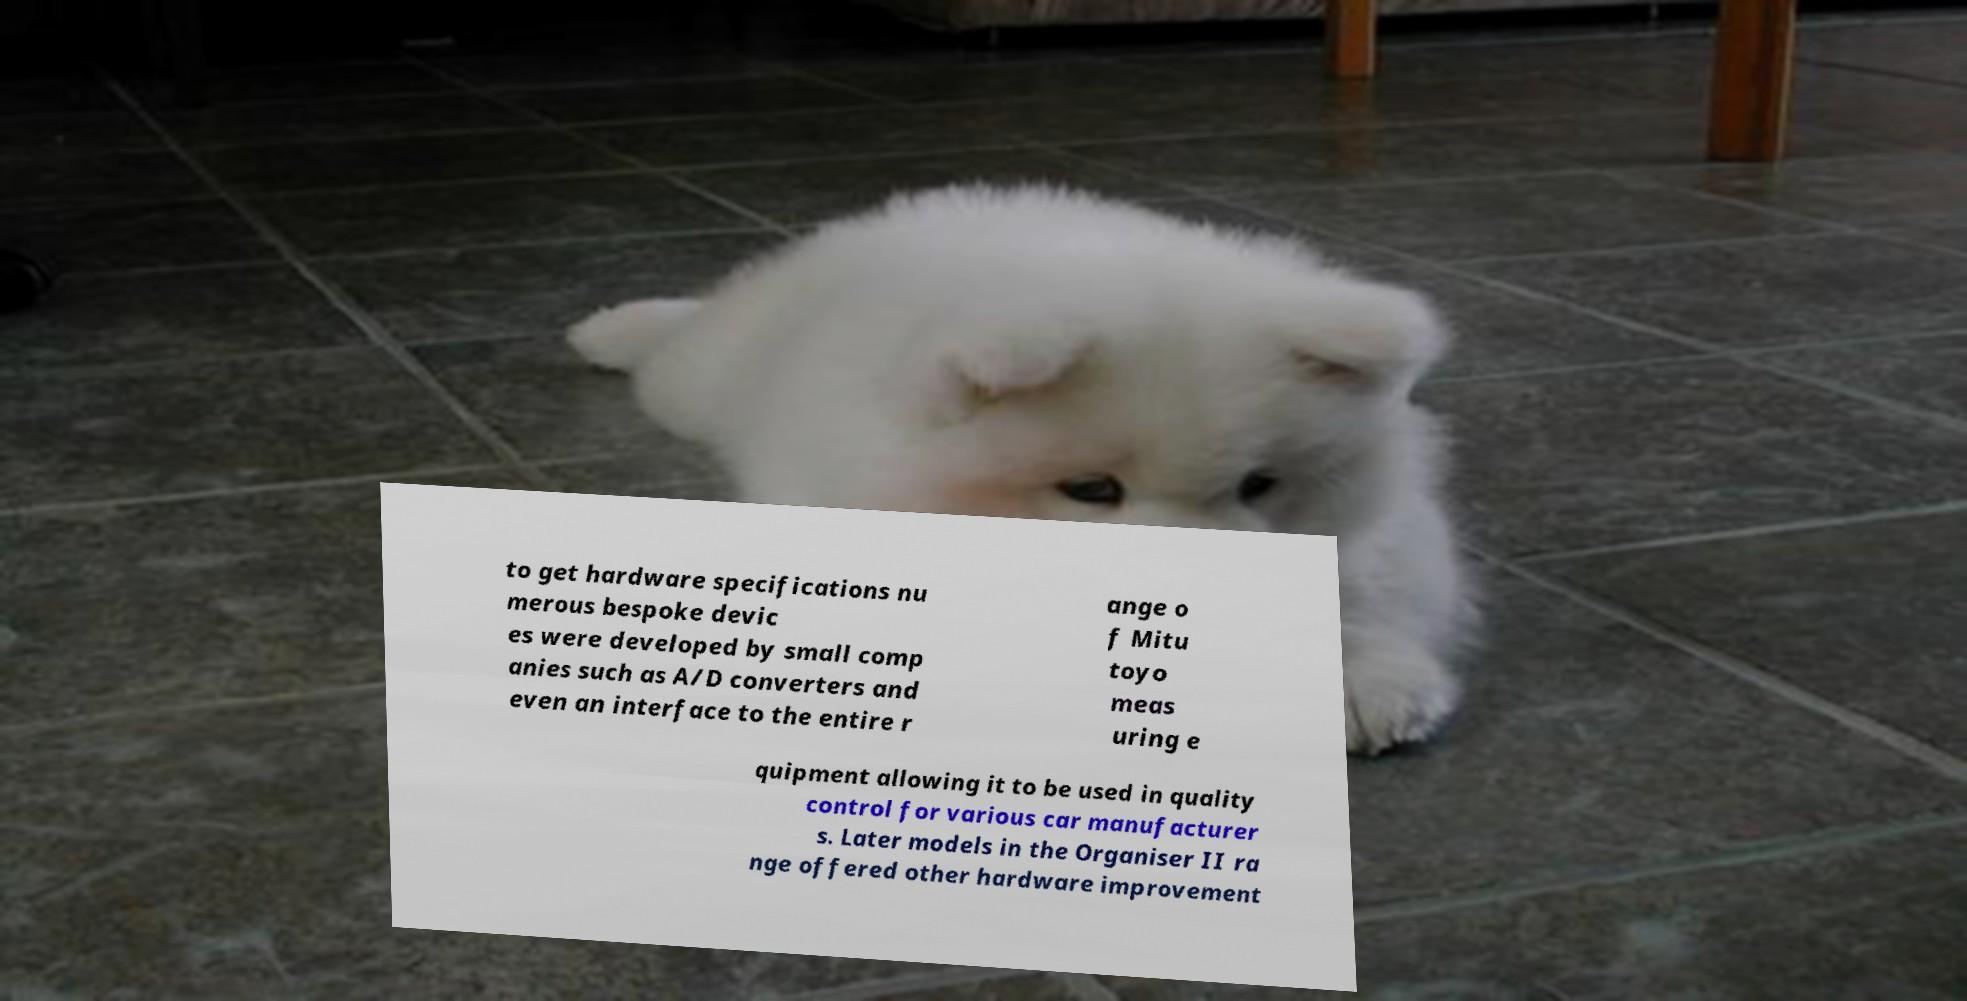There's text embedded in this image that I need extracted. Can you transcribe it verbatim? to get hardware specifications nu merous bespoke devic es were developed by small comp anies such as A/D converters and even an interface to the entire r ange o f Mitu toyo meas uring e quipment allowing it to be used in quality control for various car manufacturer s. Later models in the Organiser II ra nge offered other hardware improvement 